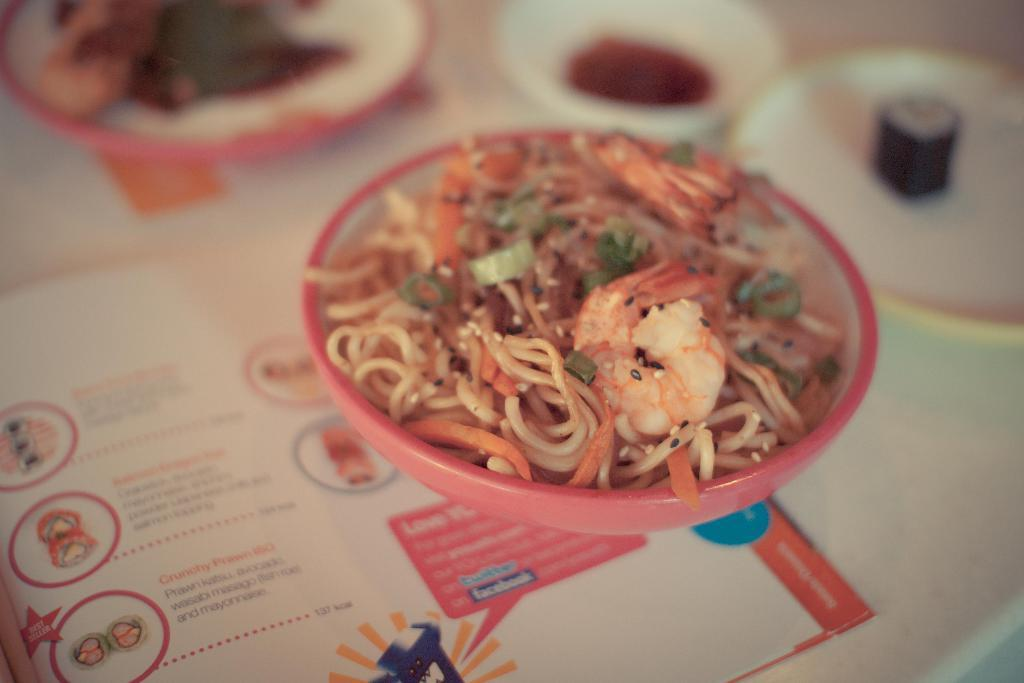What is on the plate in the image? There are food items on a plate in the image. What is the plate resting on? The plate is on paper. Where is the paper located? The paper is on a table. Can you describe the top part of the image? The top part of the image is blurred. What type of wood can be seen in the image? There is no wood present in the image. How many roses are on the table in the image? There are no roses present in the image. 